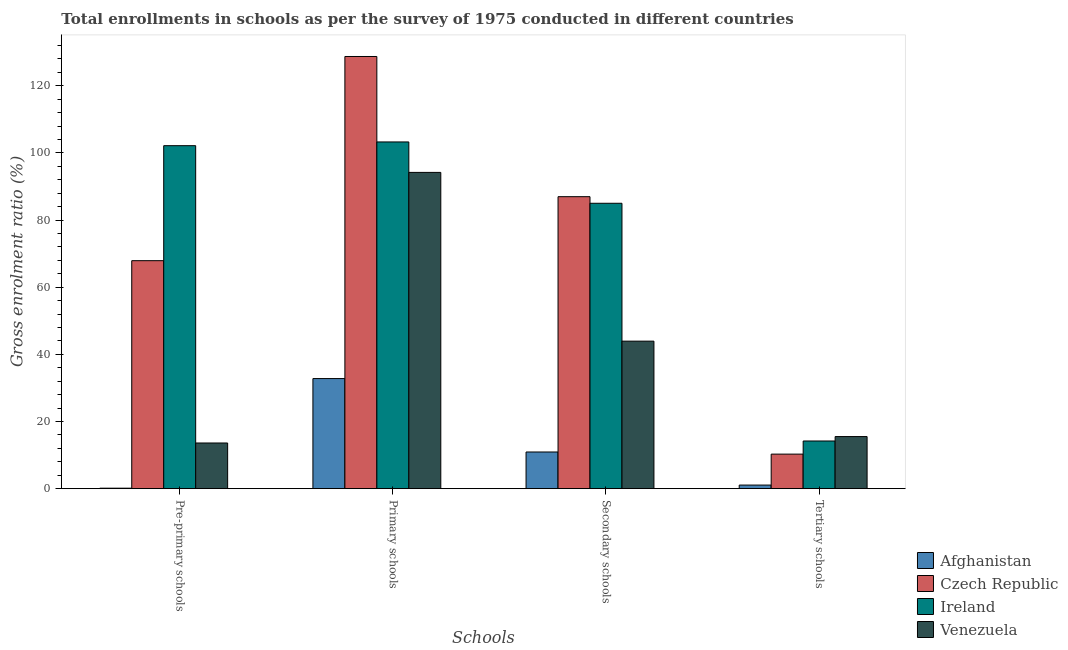How many different coloured bars are there?
Your answer should be compact. 4. How many groups of bars are there?
Your answer should be very brief. 4. How many bars are there on the 4th tick from the right?
Provide a succinct answer. 4. What is the label of the 2nd group of bars from the left?
Make the answer very short. Primary schools. What is the gross enrolment ratio in pre-primary schools in Ireland?
Your response must be concise. 102.14. Across all countries, what is the maximum gross enrolment ratio in pre-primary schools?
Ensure brevity in your answer.  102.14. Across all countries, what is the minimum gross enrolment ratio in primary schools?
Keep it short and to the point. 32.79. In which country was the gross enrolment ratio in primary schools maximum?
Keep it short and to the point. Czech Republic. In which country was the gross enrolment ratio in primary schools minimum?
Give a very brief answer. Afghanistan. What is the total gross enrolment ratio in pre-primary schools in the graph?
Give a very brief answer. 183.79. What is the difference between the gross enrolment ratio in pre-primary schools in Ireland and that in Czech Republic?
Keep it short and to the point. 34.24. What is the difference between the gross enrolment ratio in secondary schools in Afghanistan and the gross enrolment ratio in primary schools in Ireland?
Offer a very short reply. -92.33. What is the average gross enrolment ratio in pre-primary schools per country?
Your answer should be compact. 45.95. What is the difference between the gross enrolment ratio in secondary schools and gross enrolment ratio in primary schools in Czech Republic?
Provide a short and direct response. -41.75. In how many countries, is the gross enrolment ratio in primary schools greater than 104 %?
Your answer should be very brief. 1. What is the ratio of the gross enrolment ratio in primary schools in Venezuela to that in Ireland?
Make the answer very short. 0.91. Is the gross enrolment ratio in primary schools in Ireland less than that in Venezuela?
Offer a terse response. No. Is the difference between the gross enrolment ratio in primary schools in Venezuela and Afghanistan greater than the difference between the gross enrolment ratio in secondary schools in Venezuela and Afghanistan?
Offer a terse response. Yes. What is the difference between the highest and the second highest gross enrolment ratio in tertiary schools?
Keep it short and to the point. 1.32. What is the difference between the highest and the lowest gross enrolment ratio in primary schools?
Your answer should be compact. 95.91. Is it the case that in every country, the sum of the gross enrolment ratio in tertiary schools and gross enrolment ratio in pre-primary schools is greater than the sum of gross enrolment ratio in primary schools and gross enrolment ratio in secondary schools?
Your answer should be compact. No. What does the 3rd bar from the left in Secondary schools represents?
Offer a terse response. Ireland. What does the 1st bar from the right in Primary schools represents?
Provide a short and direct response. Venezuela. Are all the bars in the graph horizontal?
Offer a very short reply. No. What is the difference between two consecutive major ticks on the Y-axis?
Provide a succinct answer. 20. Are the values on the major ticks of Y-axis written in scientific E-notation?
Offer a terse response. No. Does the graph contain grids?
Your response must be concise. No. Where does the legend appear in the graph?
Give a very brief answer. Bottom right. How are the legend labels stacked?
Your answer should be compact. Vertical. What is the title of the graph?
Offer a very short reply. Total enrollments in schools as per the survey of 1975 conducted in different countries. Does "Macao" appear as one of the legend labels in the graph?
Give a very brief answer. No. What is the label or title of the X-axis?
Provide a short and direct response. Schools. What is the label or title of the Y-axis?
Give a very brief answer. Gross enrolment ratio (%). What is the Gross enrolment ratio (%) of Afghanistan in Pre-primary schools?
Make the answer very short. 0.15. What is the Gross enrolment ratio (%) of Czech Republic in Pre-primary schools?
Ensure brevity in your answer.  67.9. What is the Gross enrolment ratio (%) in Ireland in Pre-primary schools?
Provide a short and direct response. 102.14. What is the Gross enrolment ratio (%) of Venezuela in Pre-primary schools?
Give a very brief answer. 13.6. What is the Gross enrolment ratio (%) of Afghanistan in Primary schools?
Keep it short and to the point. 32.79. What is the Gross enrolment ratio (%) of Czech Republic in Primary schools?
Provide a short and direct response. 128.7. What is the Gross enrolment ratio (%) of Ireland in Primary schools?
Offer a very short reply. 103.25. What is the Gross enrolment ratio (%) of Venezuela in Primary schools?
Your answer should be compact. 94.18. What is the Gross enrolment ratio (%) of Afghanistan in Secondary schools?
Your response must be concise. 10.93. What is the Gross enrolment ratio (%) in Czech Republic in Secondary schools?
Ensure brevity in your answer.  86.95. What is the Gross enrolment ratio (%) in Ireland in Secondary schools?
Provide a succinct answer. 84.99. What is the Gross enrolment ratio (%) of Venezuela in Secondary schools?
Make the answer very short. 43.93. What is the Gross enrolment ratio (%) in Afghanistan in Tertiary schools?
Make the answer very short. 1.07. What is the Gross enrolment ratio (%) in Czech Republic in Tertiary schools?
Provide a succinct answer. 10.29. What is the Gross enrolment ratio (%) of Ireland in Tertiary schools?
Your response must be concise. 14.2. What is the Gross enrolment ratio (%) in Venezuela in Tertiary schools?
Your answer should be very brief. 15.51. Across all Schools, what is the maximum Gross enrolment ratio (%) of Afghanistan?
Provide a succinct answer. 32.79. Across all Schools, what is the maximum Gross enrolment ratio (%) in Czech Republic?
Keep it short and to the point. 128.7. Across all Schools, what is the maximum Gross enrolment ratio (%) of Ireland?
Provide a short and direct response. 103.25. Across all Schools, what is the maximum Gross enrolment ratio (%) of Venezuela?
Make the answer very short. 94.18. Across all Schools, what is the minimum Gross enrolment ratio (%) in Afghanistan?
Your answer should be compact. 0.15. Across all Schools, what is the minimum Gross enrolment ratio (%) of Czech Republic?
Offer a very short reply. 10.29. Across all Schools, what is the minimum Gross enrolment ratio (%) of Ireland?
Keep it short and to the point. 14.2. Across all Schools, what is the minimum Gross enrolment ratio (%) in Venezuela?
Make the answer very short. 13.6. What is the total Gross enrolment ratio (%) in Afghanistan in the graph?
Provide a succinct answer. 44.93. What is the total Gross enrolment ratio (%) in Czech Republic in the graph?
Offer a terse response. 293.84. What is the total Gross enrolment ratio (%) of Ireland in the graph?
Offer a terse response. 304.58. What is the total Gross enrolment ratio (%) in Venezuela in the graph?
Give a very brief answer. 167.23. What is the difference between the Gross enrolment ratio (%) in Afghanistan in Pre-primary schools and that in Primary schools?
Your answer should be very brief. -32.64. What is the difference between the Gross enrolment ratio (%) in Czech Republic in Pre-primary schools and that in Primary schools?
Offer a terse response. -60.8. What is the difference between the Gross enrolment ratio (%) of Ireland in Pre-primary schools and that in Primary schools?
Offer a terse response. -1.11. What is the difference between the Gross enrolment ratio (%) in Venezuela in Pre-primary schools and that in Primary schools?
Your answer should be very brief. -80.58. What is the difference between the Gross enrolment ratio (%) of Afghanistan in Pre-primary schools and that in Secondary schools?
Ensure brevity in your answer.  -10.78. What is the difference between the Gross enrolment ratio (%) of Czech Republic in Pre-primary schools and that in Secondary schools?
Provide a succinct answer. -19.05. What is the difference between the Gross enrolment ratio (%) in Ireland in Pre-primary schools and that in Secondary schools?
Provide a succinct answer. 17.15. What is the difference between the Gross enrolment ratio (%) of Venezuela in Pre-primary schools and that in Secondary schools?
Your answer should be compact. -30.33. What is the difference between the Gross enrolment ratio (%) of Afghanistan in Pre-primary schools and that in Tertiary schools?
Provide a short and direct response. -0.93. What is the difference between the Gross enrolment ratio (%) of Czech Republic in Pre-primary schools and that in Tertiary schools?
Give a very brief answer. 57.61. What is the difference between the Gross enrolment ratio (%) in Ireland in Pre-primary schools and that in Tertiary schools?
Offer a very short reply. 87.94. What is the difference between the Gross enrolment ratio (%) in Venezuela in Pre-primary schools and that in Tertiary schools?
Offer a very short reply. -1.91. What is the difference between the Gross enrolment ratio (%) in Afghanistan in Primary schools and that in Secondary schools?
Provide a short and direct response. 21.86. What is the difference between the Gross enrolment ratio (%) in Czech Republic in Primary schools and that in Secondary schools?
Make the answer very short. 41.75. What is the difference between the Gross enrolment ratio (%) in Ireland in Primary schools and that in Secondary schools?
Your answer should be compact. 18.26. What is the difference between the Gross enrolment ratio (%) in Venezuela in Primary schools and that in Secondary schools?
Make the answer very short. 50.25. What is the difference between the Gross enrolment ratio (%) in Afghanistan in Primary schools and that in Tertiary schools?
Your response must be concise. 31.71. What is the difference between the Gross enrolment ratio (%) of Czech Republic in Primary schools and that in Tertiary schools?
Keep it short and to the point. 118.41. What is the difference between the Gross enrolment ratio (%) of Ireland in Primary schools and that in Tertiary schools?
Ensure brevity in your answer.  89.06. What is the difference between the Gross enrolment ratio (%) of Venezuela in Primary schools and that in Tertiary schools?
Your answer should be compact. 78.67. What is the difference between the Gross enrolment ratio (%) in Afghanistan in Secondary schools and that in Tertiary schools?
Offer a very short reply. 9.85. What is the difference between the Gross enrolment ratio (%) of Czech Republic in Secondary schools and that in Tertiary schools?
Your response must be concise. 76.66. What is the difference between the Gross enrolment ratio (%) in Ireland in Secondary schools and that in Tertiary schools?
Provide a short and direct response. 70.79. What is the difference between the Gross enrolment ratio (%) of Venezuela in Secondary schools and that in Tertiary schools?
Your answer should be compact. 28.42. What is the difference between the Gross enrolment ratio (%) of Afghanistan in Pre-primary schools and the Gross enrolment ratio (%) of Czech Republic in Primary schools?
Your answer should be compact. -128.55. What is the difference between the Gross enrolment ratio (%) of Afghanistan in Pre-primary schools and the Gross enrolment ratio (%) of Ireland in Primary schools?
Provide a succinct answer. -103.11. What is the difference between the Gross enrolment ratio (%) of Afghanistan in Pre-primary schools and the Gross enrolment ratio (%) of Venezuela in Primary schools?
Your answer should be compact. -94.03. What is the difference between the Gross enrolment ratio (%) in Czech Republic in Pre-primary schools and the Gross enrolment ratio (%) in Ireland in Primary schools?
Offer a very short reply. -35.36. What is the difference between the Gross enrolment ratio (%) in Czech Republic in Pre-primary schools and the Gross enrolment ratio (%) in Venezuela in Primary schools?
Offer a terse response. -26.29. What is the difference between the Gross enrolment ratio (%) in Ireland in Pre-primary schools and the Gross enrolment ratio (%) in Venezuela in Primary schools?
Your response must be concise. 7.96. What is the difference between the Gross enrolment ratio (%) in Afghanistan in Pre-primary schools and the Gross enrolment ratio (%) in Czech Republic in Secondary schools?
Give a very brief answer. -86.8. What is the difference between the Gross enrolment ratio (%) in Afghanistan in Pre-primary schools and the Gross enrolment ratio (%) in Ireland in Secondary schools?
Provide a short and direct response. -84.84. What is the difference between the Gross enrolment ratio (%) in Afghanistan in Pre-primary schools and the Gross enrolment ratio (%) in Venezuela in Secondary schools?
Keep it short and to the point. -43.78. What is the difference between the Gross enrolment ratio (%) of Czech Republic in Pre-primary schools and the Gross enrolment ratio (%) of Ireland in Secondary schools?
Your response must be concise. -17.09. What is the difference between the Gross enrolment ratio (%) of Czech Republic in Pre-primary schools and the Gross enrolment ratio (%) of Venezuela in Secondary schools?
Make the answer very short. 23.96. What is the difference between the Gross enrolment ratio (%) of Ireland in Pre-primary schools and the Gross enrolment ratio (%) of Venezuela in Secondary schools?
Offer a very short reply. 58.21. What is the difference between the Gross enrolment ratio (%) in Afghanistan in Pre-primary schools and the Gross enrolment ratio (%) in Czech Republic in Tertiary schools?
Your response must be concise. -10.14. What is the difference between the Gross enrolment ratio (%) of Afghanistan in Pre-primary schools and the Gross enrolment ratio (%) of Ireland in Tertiary schools?
Your answer should be very brief. -14.05. What is the difference between the Gross enrolment ratio (%) of Afghanistan in Pre-primary schools and the Gross enrolment ratio (%) of Venezuela in Tertiary schools?
Give a very brief answer. -15.37. What is the difference between the Gross enrolment ratio (%) of Czech Republic in Pre-primary schools and the Gross enrolment ratio (%) of Ireland in Tertiary schools?
Keep it short and to the point. 53.7. What is the difference between the Gross enrolment ratio (%) of Czech Republic in Pre-primary schools and the Gross enrolment ratio (%) of Venezuela in Tertiary schools?
Provide a succinct answer. 52.38. What is the difference between the Gross enrolment ratio (%) of Ireland in Pre-primary schools and the Gross enrolment ratio (%) of Venezuela in Tertiary schools?
Provide a succinct answer. 86.62. What is the difference between the Gross enrolment ratio (%) in Afghanistan in Primary schools and the Gross enrolment ratio (%) in Czech Republic in Secondary schools?
Your answer should be compact. -54.16. What is the difference between the Gross enrolment ratio (%) of Afghanistan in Primary schools and the Gross enrolment ratio (%) of Ireland in Secondary schools?
Your answer should be very brief. -52.2. What is the difference between the Gross enrolment ratio (%) in Afghanistan in Primary schools and the Gross enrolment ratio (%) in Venezuela in Secondary schools?
Your response must be concise. -11.15. What is the difference between the Gross enrolment ratio (%) in Czech Republic in Primary schools and the Gross enrolment ratio (%) in Ireland in Secondary schools?
Ensure brevity in your answer.  43.71. What is the difference between the Gross enrolment ratio (%) of Czech Republic in Primary schools and the Gross enrolment ratio (%) of Venezuela in Secondary schools?
Make the answer very short. 84.77. What is the difference between the Gross enrolment ratio (%) of Ireland in Primary schools and the Gross enrolment ratio (%) of Venezuela in Secondary schools?
Your answer should be compact. 59.32. What is the difference between the Gross enrolment ratio (%) in Afghanistan in Primary schools and the Gross enrolment ratio (%) in Czech Republic in Tertiary schools?
Provide a short and direct response. 22.5. What is the difference between the Gross enrolment ratio (%) in Afghanistan in Primary schools and the Gross enrolment ratio (%) in Ireland in Tertiary schools?
Give a very brief answer. 18.59. What is the difference between the Gross enrolment ratio (%) in Afghanistan in Primary schools and the Gross enrolment ratio (%) in Venezuela in Tertiary schools?
Keep it short and to the point. 17.27. What is the difference between the Gross enrolment ratio (%) in Czech Republic in Primary schools and the Gross enrolment ratio (%) in Ireland in Tertiary schools?
Your response must be concise. 114.5. What is the difference between the Gross enrolment ratio (%) of Czech Republic in Primary schools and the Gross enrolment ratio (%) of Venezuela in Tertiary schools?
Offer a very short reply. 113.19. What is the difference between the Gross enrolment ratio (%) in Ireland in Primary schools and the Gross enrolment ratio (%) in Venezuela in Tertiary schools?
Give a very brief answer. 87.74. What is the difference between the Gross enrolment ratio (%) of Afghanistan in Secondary schools and the Gross enrolment ratio (%) of Czech Republic in Tertiary schools?
Give a very brief answer. 0.63. What is the difference between the Gross enrolment ratio (%) in Afghanistan in Secondary schools and the Gross enrolment ratio (%) in Ireland in Tertiary schools?
Keep it short and to the point. -3.27. What is the difference between the Gross enrolment ratio (%) in Afghanistan in Secondary schools and the Gross enrolment ratio (%) in Venezuela in Tertiary schools?
Ensure brevity in your answer.  -4.59. What is the difference between the Gross enrolment ratio (%) in Czech Republic in Secondary schools and the Gross enrolment ratio (%) in Ireland in Tertiary schools?
Your answer should be compact. 72.75. What is the difference between the Gross enrolment ratio (%) in Czech Republic in Secondary schools and the Gross enrolment ratio (%) in Venezuela in Tertiary schools?
Offer a very short reply. 71.44. What is the difference between the Gross enrolment ratio (%) in Ireland in Secondary schools and the Gross enrolment ratio (%) in Venezuela in Tertiary schools?
Your answer should be compact. 69.47. What is the average Gross enrolment ratio (%) in Afghanistan per Schools?
Provide a succinct answer. 11.23. What is the average Gross enrolment ratio (%) in Czech Republic per Schools?
Give a very brief answer. 73.46. What is the average Gross enrolment ratio (%) of Ireland per Schools?
Your response must be concise. 76.15. What is the average Gross enrolment ratio (%) of Venezuela per Schools?
Your response must be concise. 41.81. What is the difference between the Gross enrolment ratio (%) in Afghanistan and Gross enrolment ratio (%) in Czech Republic in Pre-primary schools?
Provide a succinct answer. -67.75. What is the difference between the Gross enrolment ratio (%) in Afghanistan and Gross enrolment ratio (%) in Ireland in Pre-primary schools?
Offer a very short reply. -101.99. What is the difference between the Gross enrolment ratio (%) of Afghanistan and Gross enrolment ratio (%) of Venezuela in Pre-primary schools?
Offer a very short reply. -13.46. What is the difference between the Gross enrolment ratio (%) in Czech Republic and Gross enrolment ratio (%) in Ireland in Pre-primary schools?
Your response must be concise. -34.24. What is the difference between the Gross enrolment ratio (%) in Czech Republic and Gross enrolment ratio (%) in Venezuela in Pre-primary schools?
Your response must be concise. 54.29. What is the difference between the Gross enrolment ratio (%) of Ireland and Gross enrolment ratio (%) of Venezuela in Pre-primary schools?
Make the answer very short. 88.53. What is the difference between the Gross enrolment ratio (%) in Afghanistan and Gross enrolment ratio (%) in Czech Republic in Primary schools?
Make the answer very short. -95.91. What is the difference between the Gross enrolment ratio (%) of Afghanistan and Gross enrolment ratio (%) of Ireland in Primary schools?
Provide a short and direct response. -70.47. What is the difference between the Gross enrolment ratio (%) of Afghanistan and Gross enrolment ratio (%) of Venezuela in Primary schools?
Your answer should be very brief. -61.4. What is the difference between the Gross enrolment ratio (%) of Czech Republic and Gross enrolment ratio (%) of Ireland in Primary schools?
Your response must be concise. 25.45. What is the difference between the Gross enrolment ratio (%) of Czech Republic and Gross enrolment ratio (%) of Venezuela in Primary schools?
Your response must be concise. 34.52. What is the difference between the Gross enrolment ratio (%) in Ireland and Gross enrolment ratio (%) in Venezuela in Primary schools?
Make the answer very short. 9.07. What is the difference between the Gross enrolment ratio (%) in Afghanistan and Gross enrolment ratio (%) in Czech Republic in Secondary schools?
Your response must be concise. -76.03. What is the difference between the Gross enrolment ratio (%) of Afghanistan and Gross enrolment ratio (%) of Ireland in Secondary schools?
Your answer should be very brief. -74.06. What is the difference between the Gross enrolment ratio (%) in Afghanistan and Gross enrolment ratio (%) in Venezuela in Secondary schools?
Give a very brief answer. -33.01. What is the difference between the Gross enrolment ratio (%) in Czech Republic and Gross enrolment ratio (%) in Ireland in Secondary schools?
Offer a terse response. 1.96. What is the difference between the Gross enrolment ratio (%) in Czech Republic and Gross enrolment ratio (%) in Venezuela in Secondary schools?
Keep it short and to the point. 43.02. What is the difference between the Gross enrolment ratio (%) in Ireland and Gross enrolment ratio (%) in Venezuela in Secondary schools?
Your response must be concise. 41.06. What is the difference between the Gross enrolment ratio (%) of Afghanistan and Gross enrolment ratio (%) of Czech Republic in Tertiary schools?
Offer a terse response. -9.22. What is the difference between the Gross enrolment ratio (%) of Afghanistan and Gross enrolment ratio (%) of Ireland in Tertiary schools?
Offer a very short reply. -13.12. What is the difference between the Gross enrolment ratio (%) of Afghanistan and Gross enrolment ratio (%) of Venezuela in Tertiary schools?
Ensure brevity in your answer.  -14.44. What is the difference between the Gross enrolment ratio (%) in Czech Republic and Gross enrolment ratio (%) in Ireland in Tertiary schools?
Keep it short and to the point. -3.91. What is the difference between the Gross enrolment ratio (%) of Czech Republic and Gross enrolment ratio (%) of Venezuela in Tertiary schools?
Your answer should be compact. -5.22. What is the difference between the Gross enrolment ratio (%) in Ireland and Gross enrolment ratio (%) in Venezuela in Tertiary schools?
Make the answer very short. -1.32. What is the ratio of the Gross enrolment ratio (%) of Afghanistan in Pre-primary schools to that in Primary schools?
Offer a terse response. 0. What is the ratio of the Gross enrolment ratio (%) in Czech Republic in Pre-primary schools to that in Primary schools?
Provide a short and direct response. 0.53. What is the ratio of the Gross enrolment ratio (%) of Venezuela in Pre-primary schools to that in Primary schools?
Provide a short and direct response. 0.14. What is the ratio of the Gross enrolment ratio (%) in Afghanistan in Pre-primary schools to that in Secondary schools?
Keep it short and to the point. 0.01. What is the ratio of the Gross enrolment ratio (%) of Czech Republic in Pre-primary schools to that in Secondary schools?
Ensure brevity in your answer.  0.78. What is the ratio of the Gross enrolment ratio (%) in Ireland in Pre-primary schools to that in Secondary schools?
Ensure brevity in your answer.  1.2. What is the ratio of the Gross enrolment ratio (%) in Venezuela in Pre-primary schools to that in Secondary schools?
Ensure brevity in your answer.  0.31. What is the ratio of the Gross enrolment ratio (%) of Afghanistan in Pre-primary schools to that in Tertiary schools?
Your answer should be compact. 0.14. What is the ratio of the Gross enrolment ratio (%) in Czech Republic in Pre-primary schools to that in Tertiary schools?
Your answer should be compact. 6.6. What is the ratio of the Gross enrolment ratio (%) of Ireland in Pre-primary schools to that in Tertiary schools?
Provide a short and direct response. 7.19. What is the ratio of the Gross enrolment ratio (%) in Venezuela in Pre-primary schools to that in Tertiary schools?
Offer a very short reply. 0.88. What is the ratio of the Gross enrolment ratio (%) of Afghanistan in Primary schools to that in Secondary schools?
Make the answer very short. 3. What is the ratio of the Gross enrolment ratio (%) in Czech Republic in Primary schools to that in Secondary schools?
Your response must be concise. 1.48. What is the ratio of the Gross enrolment ratio (%) in Ireland in Primary schools to that in Secondary schools?
Keep it short and to the point. 1.21. What is the ratio of the Gross enrolment ratio (%) in Venezuela in Primary schools to that in Secondary schools?
Make the answer very short. 2.14. What is the ratio of the Gross enrolment ratio (%) in Afghanistan in Primary schools to that in Tertiary schools?
Give a very brief answer. 30.52. What is the ratio of the Gross enrolment ratio (%) in Czech Republic in Primary schools to that in Tertiary schools?
Make the answer very short. 12.51. What is the ratio of the Gross enrolment ratio (%) in Ireland in Primary schools to that in Tertiary schools?
Provide a short and direct response. 7.27. What is the ratio of the Gross enrolment ratio (%) of Venezuela in Primary schools to that in Tertiary schools?
Your answer should be very brief. 6.07. What is the ratio of the Gross enrolment ratio (%) in Afghanistan in Secondary schools to that in Tertiary schools?
Provide a succinct answer. 10.17. What is the ratio of the Gross enrolment ratio (%) of Czech Republic in Secondary schools to that in Tertiary schools?
Ensure brevity in your answer.  8.45. What is the ratio of the Gross enrolment ratio (%) of Ireland in Secondary schools to that in Tertiary schools?
Provide a short and direct response. 5.99. What is the ratio of the Gross enrolment ratio (%) of Venezuela in Secondary schools to that in Tertiary schools?
Give a very brief answer. 2.83. What is the difference between the highest and the second highest Gross enrolment ratio (%) in Afghanistan?
Your answer should be very brief. 21.86. What is the difference between the highest and the second highest Gross enrolment ratio (%) of Czech Republic?
Give a very brief answer. 41.75. What is the difference between the highest and the second highest Gross enrolment ratio (%) of Ireland?
Keep it short and to the point. 1.11. What is the difference between the highest and the second highest Gross enrolment ratio (%) in Venezuela?
Offer a terse response. 50.25. What is the difference between the highest and the lowest Gross enrolment ratio (%) of Afghanistan?
Ensure brevity in your answer.  32.64. What is the difference between the highest and the lowest Gross enrolment ratio (%) in Czech Republic?
Your answer should be compact. 118.41. What is the difference between the highest and the lowest Gross enrolment ratio (%) of Ireland?
Give a very brief answer. 89.06. What is the difference between the highest and the lowest Gross enrolment ratio (%) of Venezuela?
Ensure brevity in your answer.  80.58. 